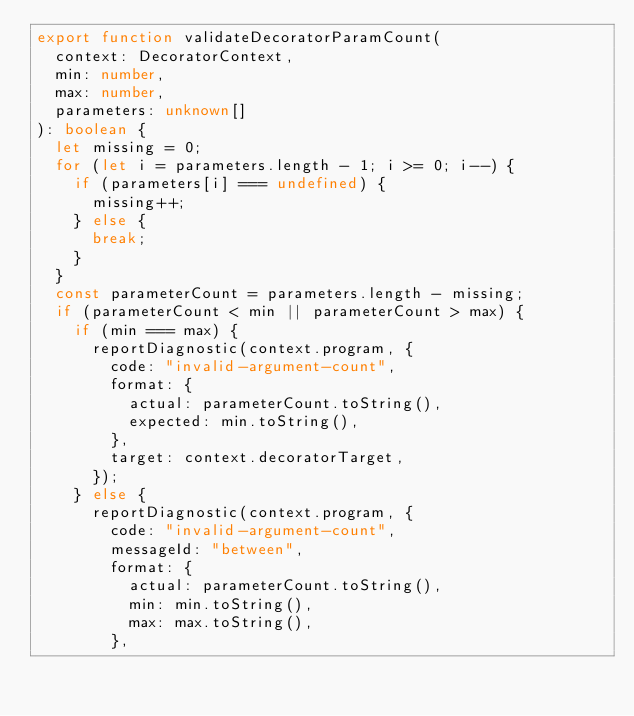<code> <loc_0><loc_0><loc_500><loc_500><_TypeScript_>export function validateDecoratorParamCount(
  context: DecoratorContext,
  min: number,
  max: number,
  parameters: unknown[]
): boolean {
  let missing = 0;
  for (let i = parameters.length - 1; i >= 0; i--) {
    if (parameters[i] === undefined) {
      missing++;
    } else {
      break;
    }
  }
  const parameterCount = parameters.length - missing;
  if (parameterCount < min || parameterCount > max) {
    if (min === max) {
      reportDiagnostic(context.program, {
        code: "invalid-argument-count",
        format: {
          actual: parameterCount.toString(),
          expected: min.toString(),
        },
        target: context.decoratorTarget,
      });
    } else {
      reportDiagnostic(context.program, {
        code: "invalid-argument-count",
        messageId: "between",
        format: {
          actual: parameterCount.toString(),
          min: min.toString(),
          max: max.toString(),
        },</code> 